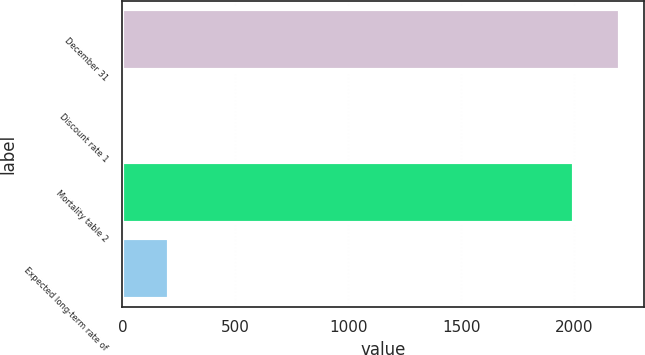Convert chart. <chart><loc_0><loc_0><loc_500><loc_500><bar_chart><fcel>December 31<fcel>Discount rate 1<fcel>Mortality table 2<fcel>Expected long-term rate of<nl><fcel>2200.79<fcel>5.1<fcel>2000<fcel>205.89<nl></chart> 